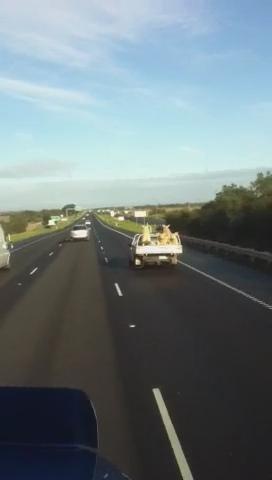Are the lines solid or dotted?
Keep it brief. Dotted. Are there trees at the side of the road?
Concise answer only. Yes. How many lanes are on the road?
Answer briefly. 3. Is this an airstrip?
Keep it brief. No. 